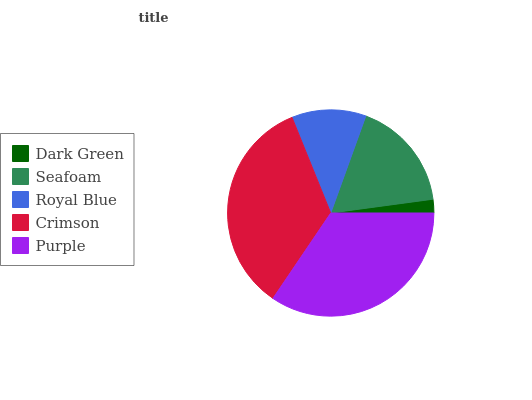Is Dark Green the minimum?
Answer yes or no. Yes. Is Purple the maximum?
Answer yes or no. Yes. Is Seafoam the minimum?
Answer yes or no. No. Is Seafoam the maximum?
Answer yes or no. No. Is Seafoam greater than Dark Green?
Answer yes or no. Yes. Is Dark Green less than Seafoam?
Answer yes or no. Yes. Is Dark Green greater than Seafoam?
Answer yes or no. No. Is Seafoam less than Dark Green?
Answer yes or no. No. Is Seafoam the high median?
Answer yes or no. Yes. Is Seafoam the low median?
Answer yes or no. Yes. Is Crimson the high median?
Answer yes or no. No. Is Crimson the low median?
Answer yes or no. No. 